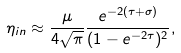<formula> <loc_0><loc_0><loc_500><loc_500>\eta _ { i n } \approx \frac { \mu } { 4 \sqrt { \pi } } \frac { e ^ { - 2 ( \tau + \sigma ) } } { ( 1 - e ^ { - 2 \tau } ) ^ { 2 } } ,</formula> 